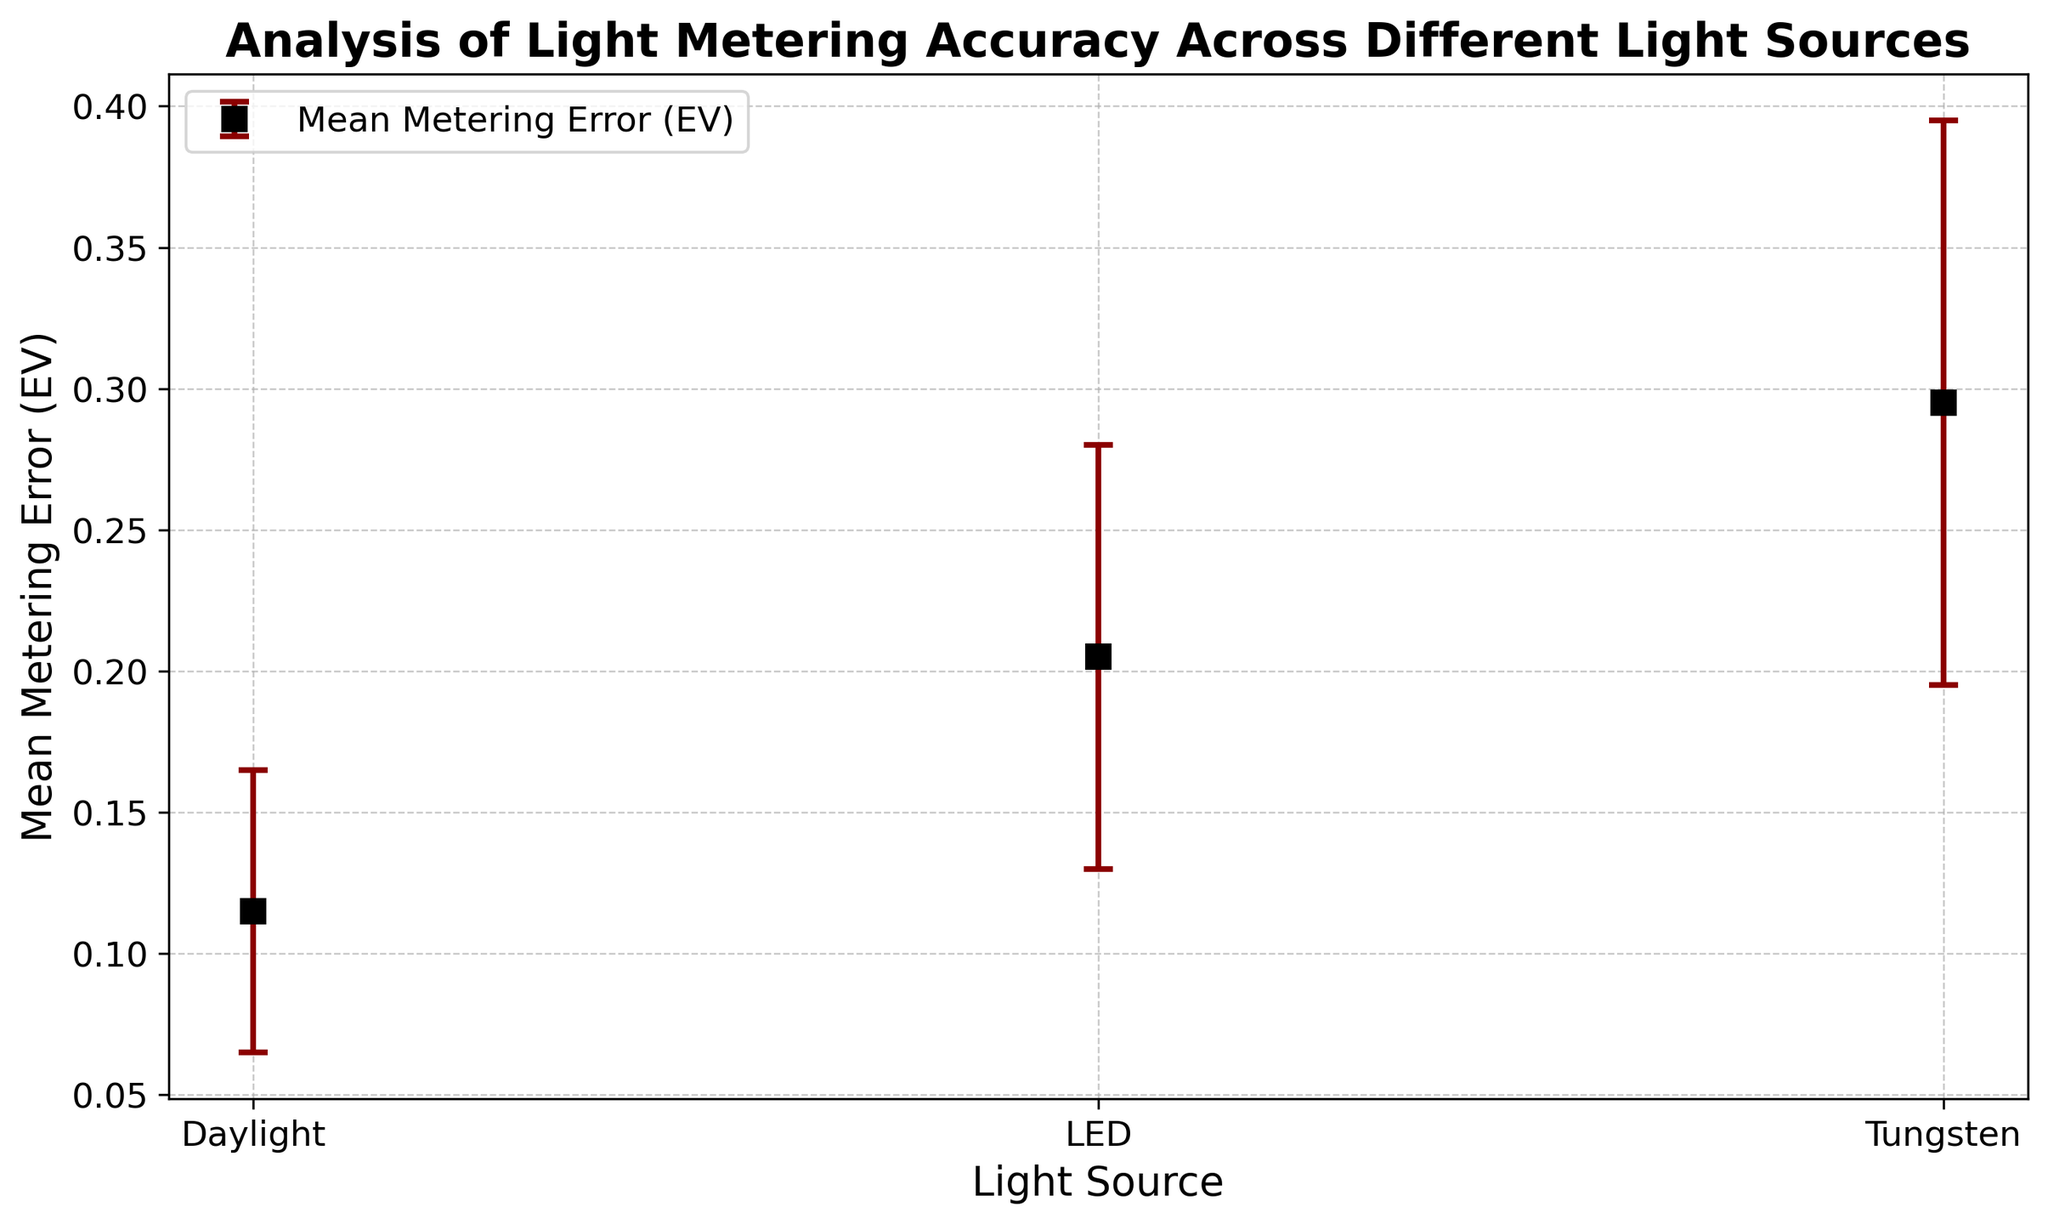Which light source has the highest mean metering error? Looking at the plot, the light source with the highest mean error bar is Tungsten.
Answer: Tungsten Which light source has the smallest standard deviation in metering error? The plot shows error bars, and the smallest deviations (shortest error bars) are observed for Daylight.
Answer: Daylight What is the approximate difference in mean metering error between Tungsten and LED? From the error bar plot, Tungsten has mean metering error of ~0.30 EV and LED has ~0.20 EV. The difference is 0.30 - 0.20 EV.
Answer: 0.10 EV How do the standard deviations compare between Daylight and Tungsten? In the plot, the error bar for Daylight is shorter than that for Tungsten, indicating that Daylight has a smaller standard deviation compared to Tungsten.
Answer: Daylight < Tungsten If you sum the mean metering errors of all light sources, what is the total? The mean errors are approximately 0.115 EV (Daylight), 0.295 EV (Tungsten), and 0.205 EV (LED). Summing these values gives 0.115 + 0.295 + 0.205 = 0.615 EV.
Answer: 0.615 EV Which light source has the most consistent metering accuracy, and why? Consistency can be judged by looking at the standard deviation (shortest error bars). Daylight shows the shortest error bars indicating the most consistent metering accuracy.
Answer: Daylight Compare the range of mean metering errors for Daylight and LED. The mean metering errors for Daylight range from ~0.11 to 0.13 EV, while for LED from ~0.19 to 0.22 EV. The range for Daylight is smaller compared to LED.
Answer: Daylight < LED 